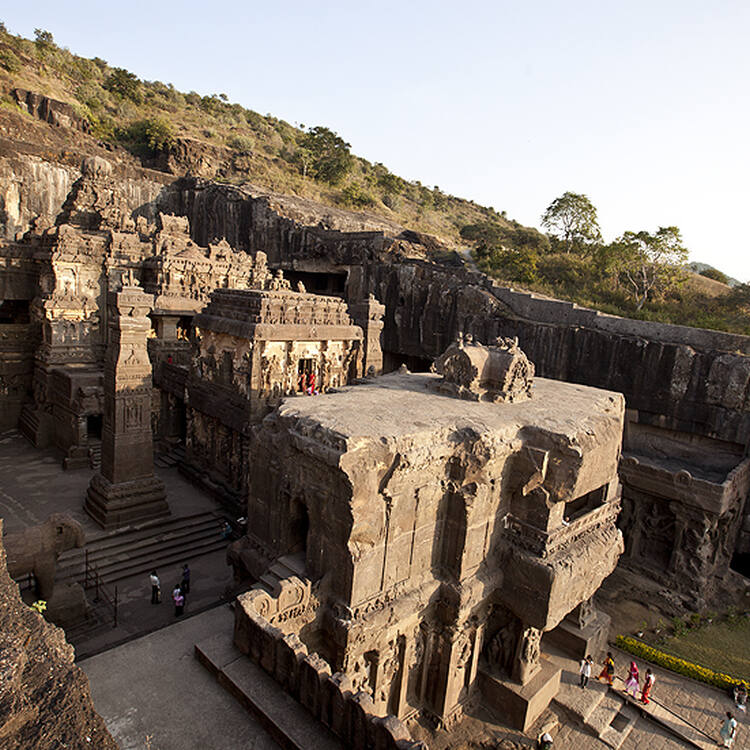What is the significance of the Ellora Caves in history? The Ellora Caves are significant in history due to their remarkable demonstration of ancient Indian rock-cut architecture. Spanning from the 6th to the 10th century, these caves exhibit the harmonious coexistence of three major religions: Hinduism, Buddhism, and Jainism. The craftsmanship reflects the religious tolerance and cultural diversity of the time. Moreover, the site offers valuable insights into the technological advancements and artistic innovations of ancient India, providing a window into the past civilizational grandeur and its religious practices. 